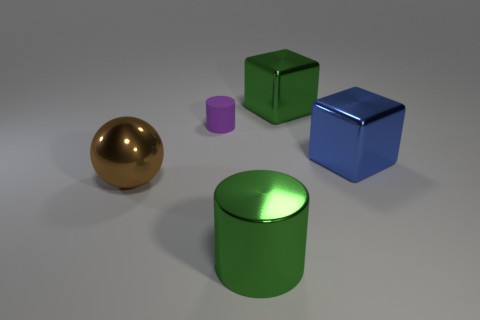Is the number of cylinders that are in front of the blue object the same as the number of big brown rubber blocks?
Keep it short and to the point. No. There is a metallic thing that is the same shape as the purple rubber object; what size is it?
Ensure brevity in your answer.  Large. There is a blue metallic object; is its shape the same as the large green metal thing that is behind the green shiny cylinder?
Offer a very short reply. Yes. There is a shiny object behind the purple rubber cylinder to the left of the large blue metallic cube; what size is it?
Keep it short and to the point. Large. Is the number of purple cylinders on the left side of the small purple rubber cylinder the same as the number of cylinders behind the big green shiny block?
Provide a succinct answer. Yes. The other large metallic thing that is the same shape as the large blue metal object is what color?
Provide a succinct answer. Green. What number of other metal cylinders have the same color as the large cylinder?
Offer a terse response. 0. There is a green metal thing to the left of the green metallic block; is it the same shape as the blue object?
Provide a succinct answer. No. What is the shape of the green metal object that is left of the large metallic cube that is left of the metallic thing that is right of the large green cube?
Offer a terse response. Cylinder. The purple cylinder is what size?
Your response must be concise. Small. 